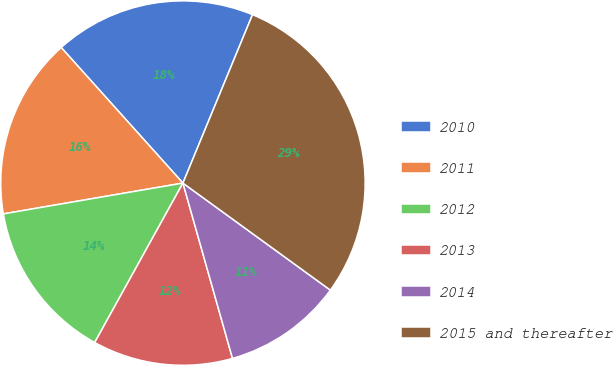Convert chart to OTSL. <chart><loc_0><loc_0><loc_500><loc_500><pie_chart><fcel>2010<fcel>2011<fcel>2012<fcel>2013<fcel>2014<fcel>2015 and thereafter<nl><fcel>17.88%<fcel>16.06%<fcel>14.25%<fcel>12.43%<fcel>10.62%<fcel>28.76%<nl></chart> 